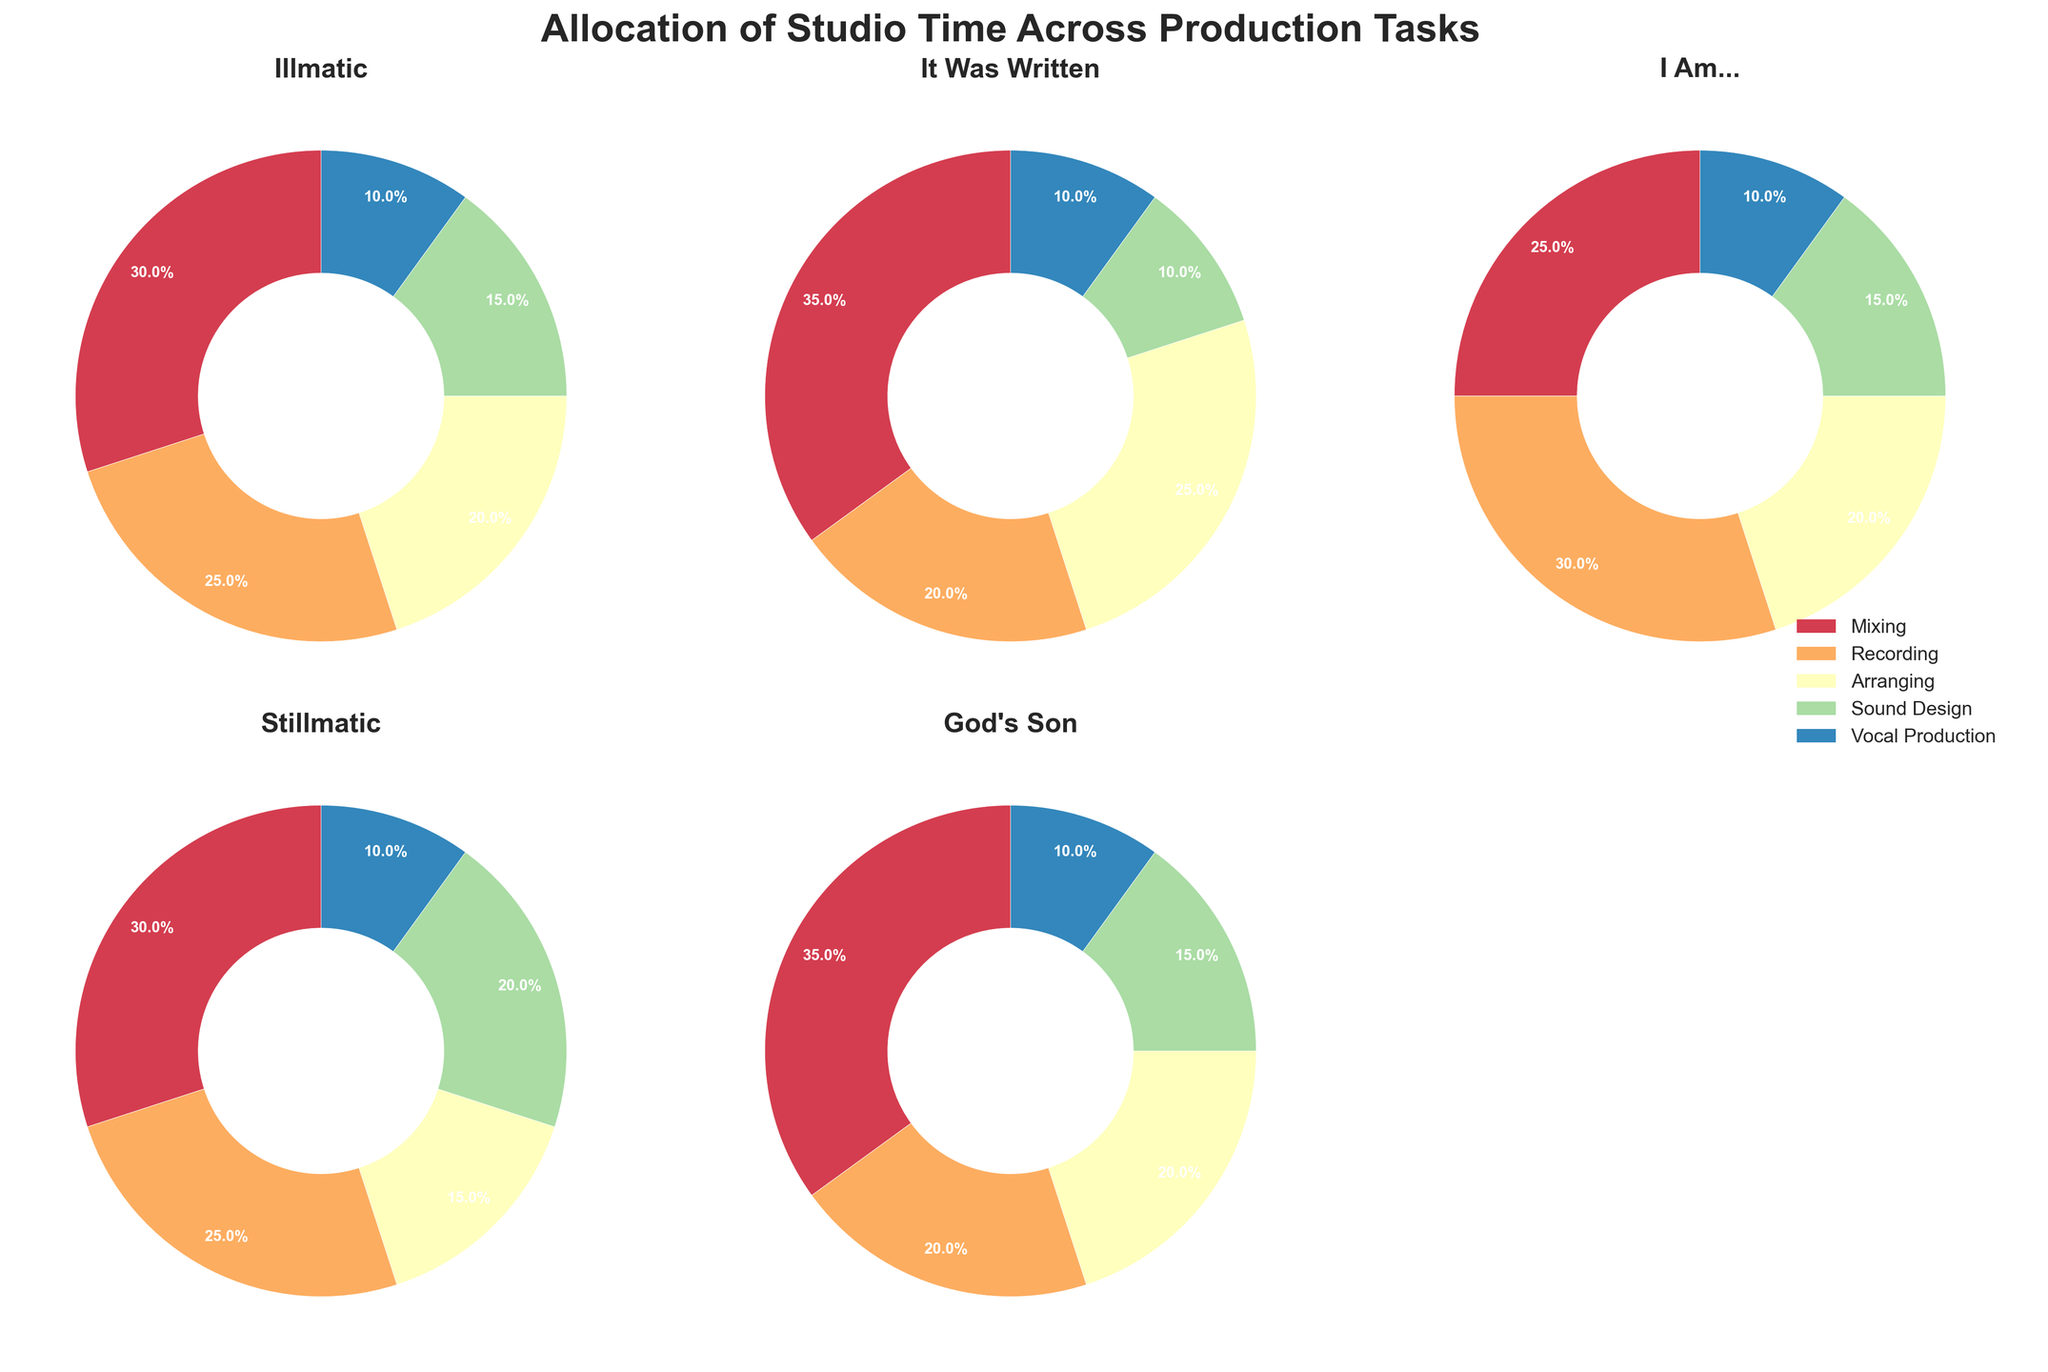How many albums are displayed in the figure? There are two rows of subplots in the figure, and each subplot represents one album. There are three subplots in the first row and two in the second row, resulting in a total of five albums displayed.
Answer: Five Which album has the highest percentage of time allocated to Mixing? Scan all the subplots' pie charts to check the segment labeled "Mixing." The largest percentage allocated to Mixing is 35%, which appears in the subplots for "It Was Written" and "God's Son."
Answer: It Was Written, God's Son What is the combined percentage time spent on Vocal Production across all albums? Each album has 10% time spent on Vocal Production. Adding the percentages for all albums gives (10+10+10+10+10) = 50%.
Answer: 50% Which production task uses the least amount of studio time on the album Stillmatic? Examine the pie chart for Stillmatic and identify the smallest segment. The smallest segment is Vocal Production, which uses 10% of the studio time.
Answer: Vocal Production Between the albums Illmatic and I Am..., which one allocates more time to Sound Design? Look at the pie charts for "Illmatic" and "I Am...". In Illmatic, Sound Design is 15%, while in "I Am...", it is also 15%. Both albums allocate the same amount of time to Sound Design.
Answer: They allocate the same amount of time Which task's studio time varies the most across the different albums? Compare the percentages allocated to each task (Mixing, Recording, Arranging, Sound Design, Vocal Production) across all albums. Mixing has percentages ranging from 25% to 35%, a variation of 10%, which is the largest range among all tasks.
Answer: Mixing On average, how much time is allocated to Recording across all albums? Add the percentages for Recording across all albums (25+20+30+25+20) to get 120%. There are 5 albums, so the average is 120/5 = 24%.
Answer: 24% Which album allocates the most time to Arranging? Look for the highest percentage segment for "Arranging" across all subplots. The maximum percentage for Arranging is 25%, which appears in the album "It Was Written."
Answer: It Was Written How does the allocation of studio time for Vocal Production compare across all albums? Check the percentage spent on Vocal Production in every album. Each album allocates 10% of the studio time for Vocal Production, indicating equal allocation.
Answer: Equal allocation across all albums What proportion of the total studio time is spent on Recording in the album God's Son compared to the album I Am...? Compare the Recording segments from both albums. God's Son allocates 20% to Recording, while "I Am..." allocates 30%. Therefore, God's Son spends 2/3 of the studio time on Recording compared to "I Am...".
Answer: 2/3 